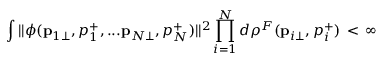Convert formula to latex. <formula><loc_0><loc_0><loc_500><loc_500>\int | | \phi ( { p } _ { 1 \bot } , p _ { 1 } ^ { + } , \dots { p } _ { N \bot } , p _ { N } ^ { + } ) | | ^ { 2 } \prod _ { i = 1 } ^ { N } d \rho ^ { F } ( { p } _ { i \bot } , p _ { i } ^ { + } ) \, < \, \infty</formula> 